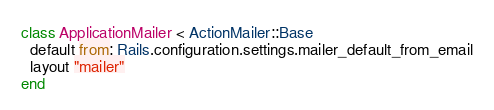Convert code to text. <code><loc_0><loc_0><loc_500><loc_500><_Ruby_>class ApplicationMailer < ActionMailer::Base
  default from: Rails.configuration.settings.mailer_default_from_email
  layout "mailer"
end
</code> 